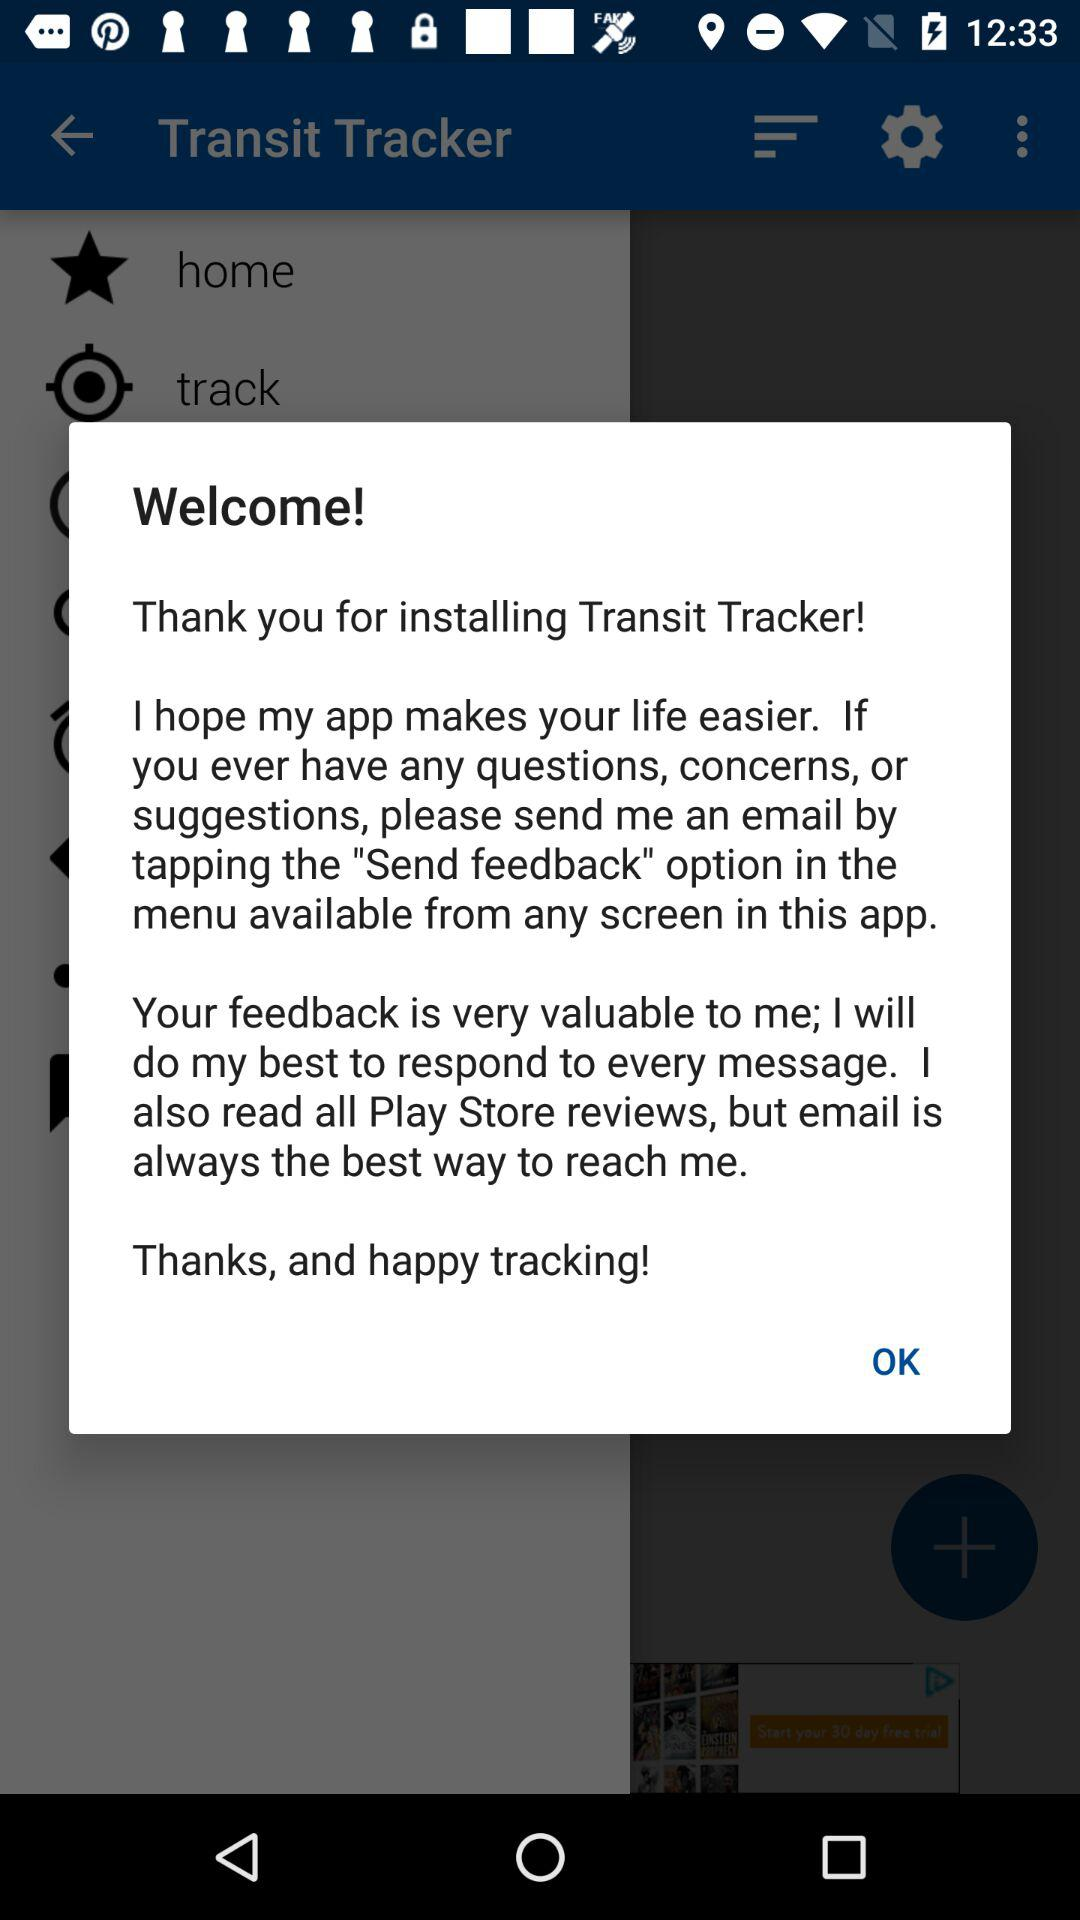What is the application name? The application name is "Transit Tracker". 